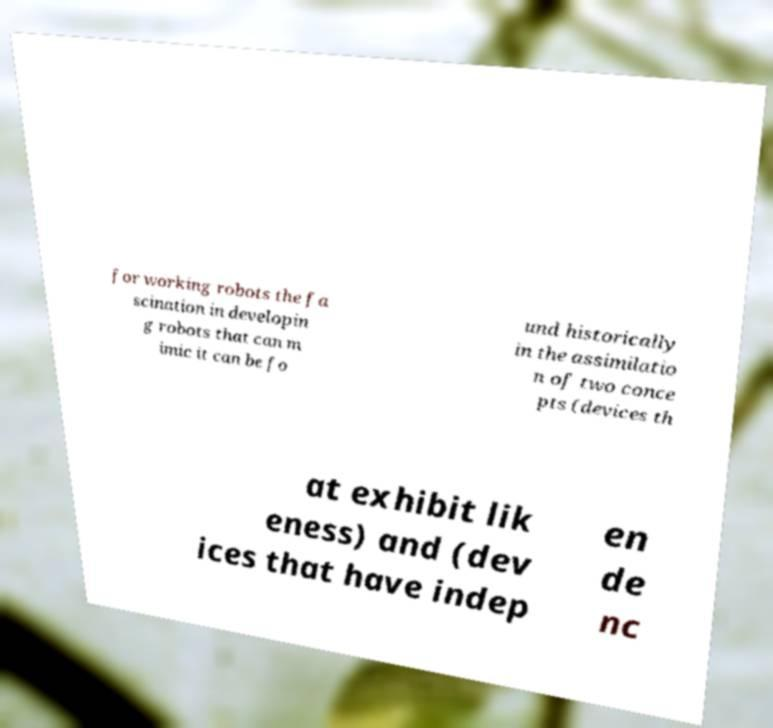Please read and relay the text visible in this image. What does it say? for working robots the fa scination in developin g robots that can m imic it can be fo und historically in the assimilatio n of two conce pts (devices th at exhibit lik eness) and (dev ices that have indep en de nc 